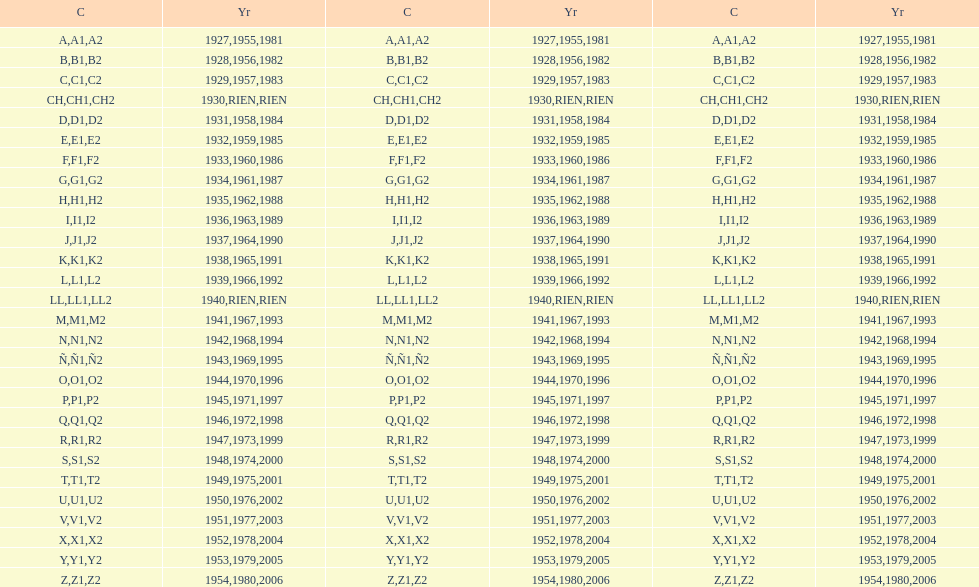Is the e code less than 1950? Yes. Can you give me this table as a dict? {'header': ['C', 'Yr', 'C', 'Yr', 'C', 'Yr'], 'rows': [['A', '1927', 'A1', '1955', 'A2', '1981'], ['B', '1928', 'B1', '1956', 'B2', '1982'], ['C', '1929', 'C1', '1957', 'C2', '1983'], ['CH', '1930', 'CH1', 'RIEN', 'CH2', 'RIEN'], ['D', '1931', 'D1', '1958', 'D2', '1984'], ['E', '1932', 'E1', '1959', 'E2', '1985'], ['F', '1933', 'F1', '1960', 'F2', '1986'], ['G', '1934', 'G1', '1961', 'G2', '1987'], ['H', '1935', 'H1', '1962', 'H2', '1988'], ['I', '1936', 'I1', '1963', 'I2', '1989'], ['J', '1937', 'J1', '1964', 'J2', '1990'], ['K', '1938', 'K1', '1965', 'K2', '1991'], ['L', '1939', 'L1', '1966', 'L2', '1992'], ['LL', '1940', 'LL1', 'RIEN', 'LL2', 'RIEN'], ['M', '1941', 'M1', '1967', 'M2', '1993'], ['N', '1942', 'N1', '1968', 'N2', '1994'], ['Ñ', '1943', 'Ñ1', '1969', 'Ñ2', '1995'], ['O', '1944', 'O1', '1970', 'O2', '1996'], ['P', '1945', 'P1', '1971', 'P2', '1997'], ['Q', '1946', 'Q1', '1972', 'Q2', '1998'], ['R', '1947', 'R1', '1973', 'R2', '1999'], ['S', '1948', 'S1', '1974', 'S2', '2000'], ['T', '1949', 'T1', '1975', 'T2', '2001'], ['U', '1950', 'U1', '1976', 'U2', '2002'], ['V', '1951', 'V1', '1977', 'V2', '2003'], ['X', '1952', 'X1', '1978', 'X2', '2004'], ['Y', '1953', 'Y1', '1979', 'Y2', '2005'], ['Z', '1954', 'Z1', '1980', 'Z2', '2006']]} 